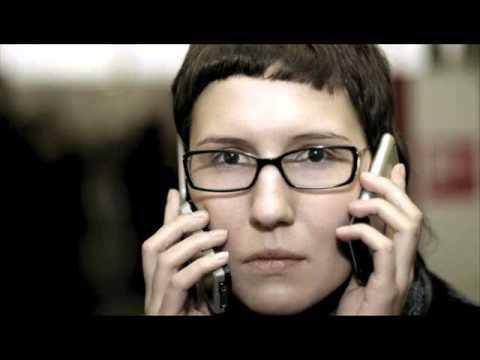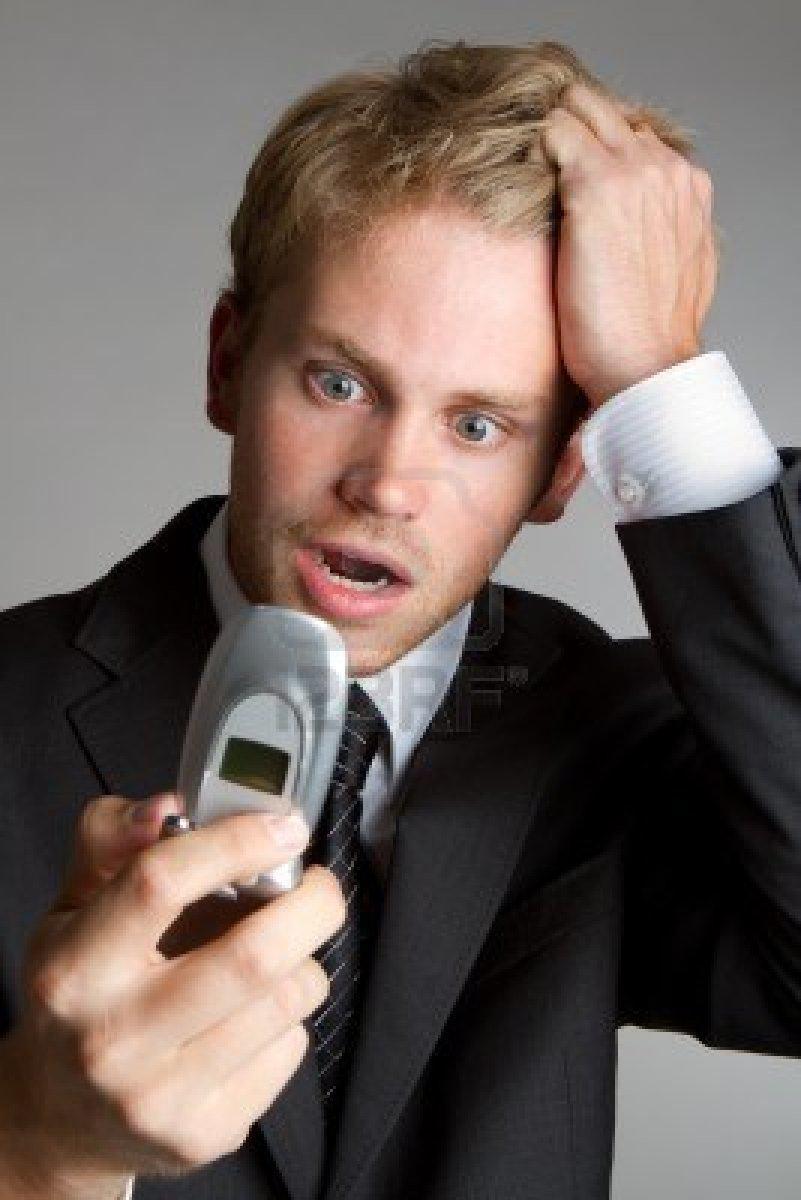The first image is the image on the left, the second image is the image on the right. Examine the images to the left and right. Is the description "There is exactly one person in every photo, and the person on the left is interacting with two phones at once, while the person on the right is showing an emotion and interacting with only one phone." accurate? Answer yes or no. Yes. The first image is the image on the left, the second image is the image on the right. For the images shown, is this caption "One image shows a smiling woman holding a phone to her ear, and the other image features a man in a dark suit with something next to his ear and something held in front of him." true? Answer yes or no. No. 